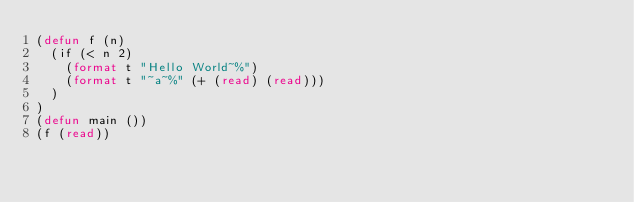Convert code to text. <code><loc_0><loc_0><loc_500><loc_500><_Lisp_>(defun f (n)
	(if (< n 2)
		(format t "Hello World~%")
		(format t "~a~%" (+ (read) (read)))
	)
)
(defun main ())
(f (read))
</code> 